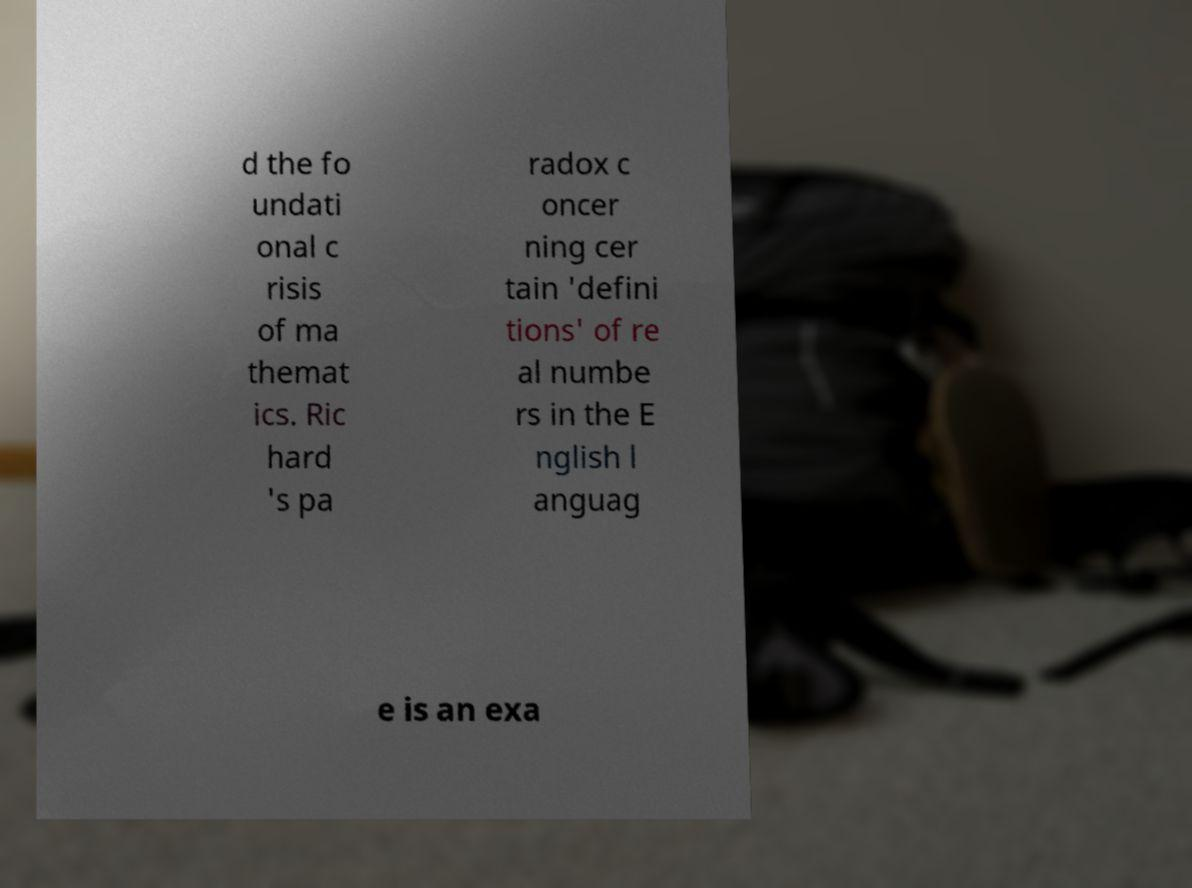Could you extract and type out the text from this image? d the fo undati onal c risis of ma themat ics. Ric hard 's pa radox c oncer ning cer tain 'defini tions' of re al numbe rs in the E nglish l anguag e is an exa 